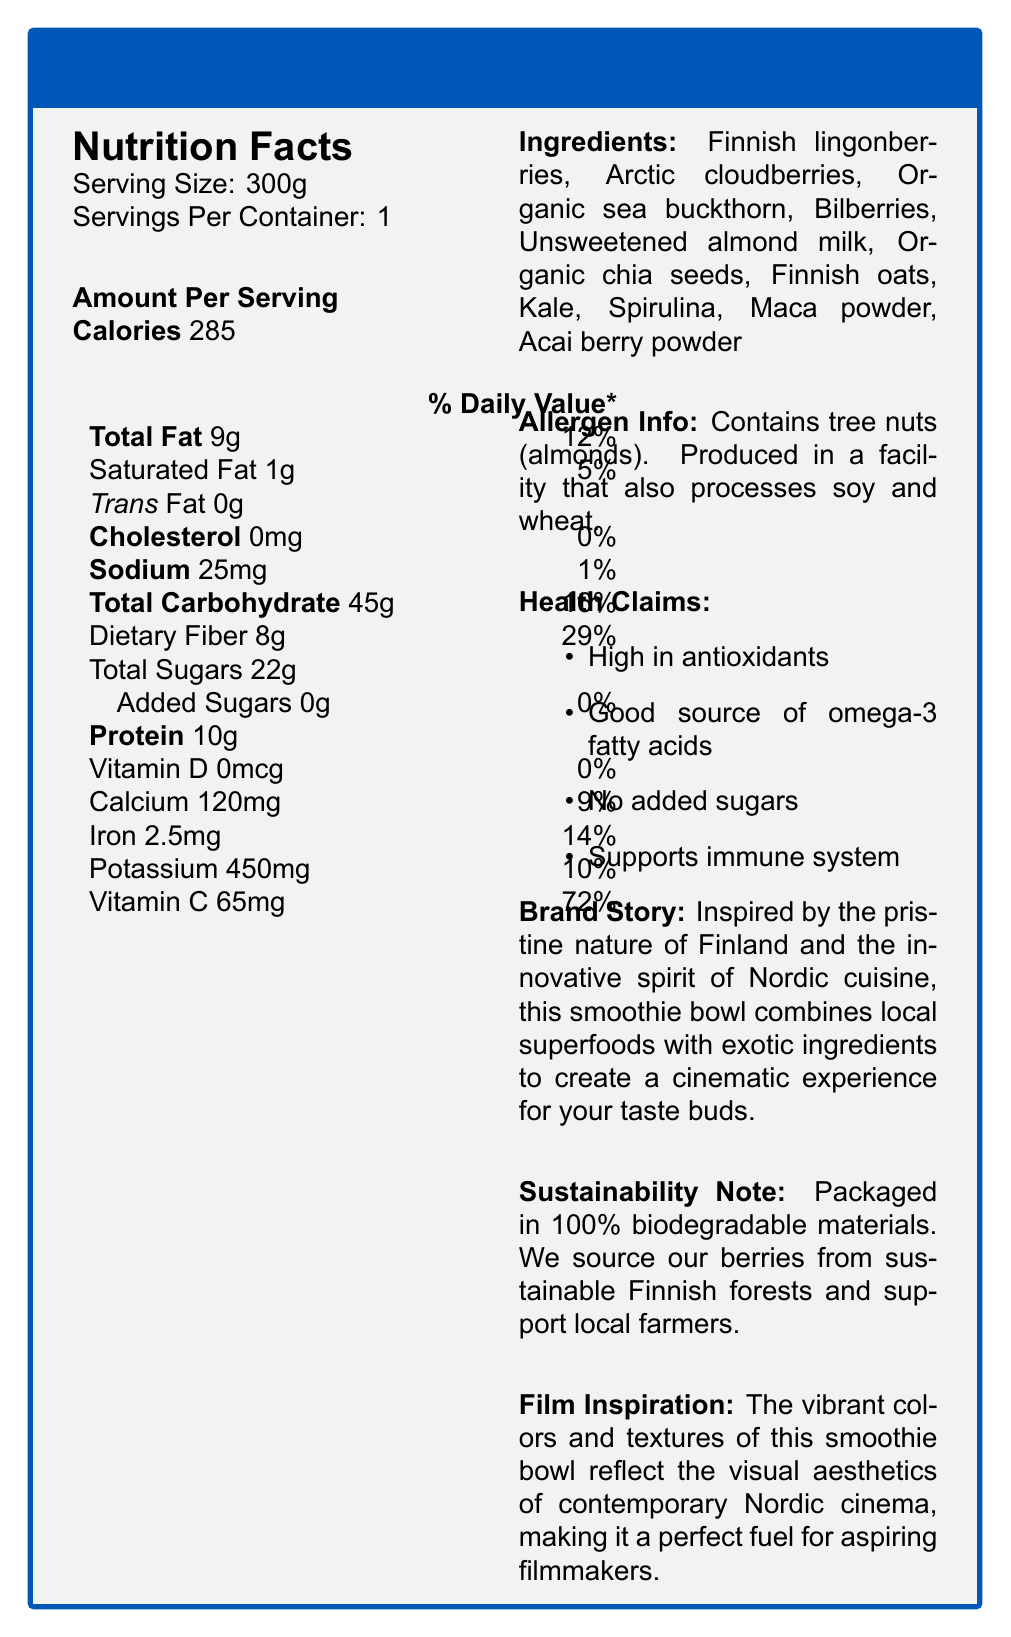what is the serving size of the Nordic Vitality Smoothie Bowl? The serving size is mentioned at the beginning of the Nutrition Facts section as "Serving Size: 300g".
Answer: 300g How many calories are in one serving of the Nordic Vitality Smoothie Bowl? The document states "Calories 285" under the Amount Per Serving section.
Answer: 285 calories What is the amount of dietary fiber per serving? Under the Total Carbohydrate section, it lists "Dietary Fiber 8g".
Answer: 8g What percentage of the Daily Value of calcium does one serving provide? The document indicates "Calcium 120mg" with a Daily Value percentage of 9%.
Answer: 9% List two local Nordic berries included in the ingredients. The ingredients section lists "Finnish lingonberries" and "Arctic cloudberries" among others.
Answer: Finnish lingonberries, Arctic cloudberries Which ingredient in the smoothie bowl is a tree nut? A. Sea buckthorn B. Almond milk C. Chia seeds D. Acai berry powder The allergen information section specifies that the product contains tree nuts (almonds), which is related to almond milk.
Answer: B. Almond milk What is the daily value percentage of Vitamin C provided by one serving? A. 65% B. 72% C. 14% D. 29% The document states "Vitamin C 65mg" with a daily value percentage of 72%.
Answer: B. 72% Does the smoothie bowl contain any added sugars? The section for added sugars states "0g" with a daily value of "0%".
Answer: No Is this product suitable for someone with a gluten allergy? Although the product does not list gluten as an ingredient, the allergen information states it is produced in a facility that processes wheat.
Answer: Cannot be determined What is the main idea conveyed by the document? The document elaborates on the nutrition content, ingredients, health claims, allergen information, brand story, and sustainability note, painting a comprehensive picture of the product.
Answer: The document provides detailed nutrition and ingredient information for the Nordic Vitality Smoothie Bowl, a superfood product featuring local Nordic berries and exotic ingredients, highlighting its health benefits, sustainability practices, and its inspiration from Nordic cinema. What is the health claim related to antioxidants? The health claims section lists "High in antioxidants" as one of the claims.
Answer: High in antioxidants What is the total carbohydrate content per serving? Under the Amount Per Serving section, it shows "Total Carbohydrate 45g".
Answer: 45g Which part of the document reflects the company’s commitment to sustainability? The sustainability note mentions packaging in biodegradable materials and sourcing berries from sustainable Finnish forests while supporting local farmers.
Answer: The section titled 'Sustainability Note' 